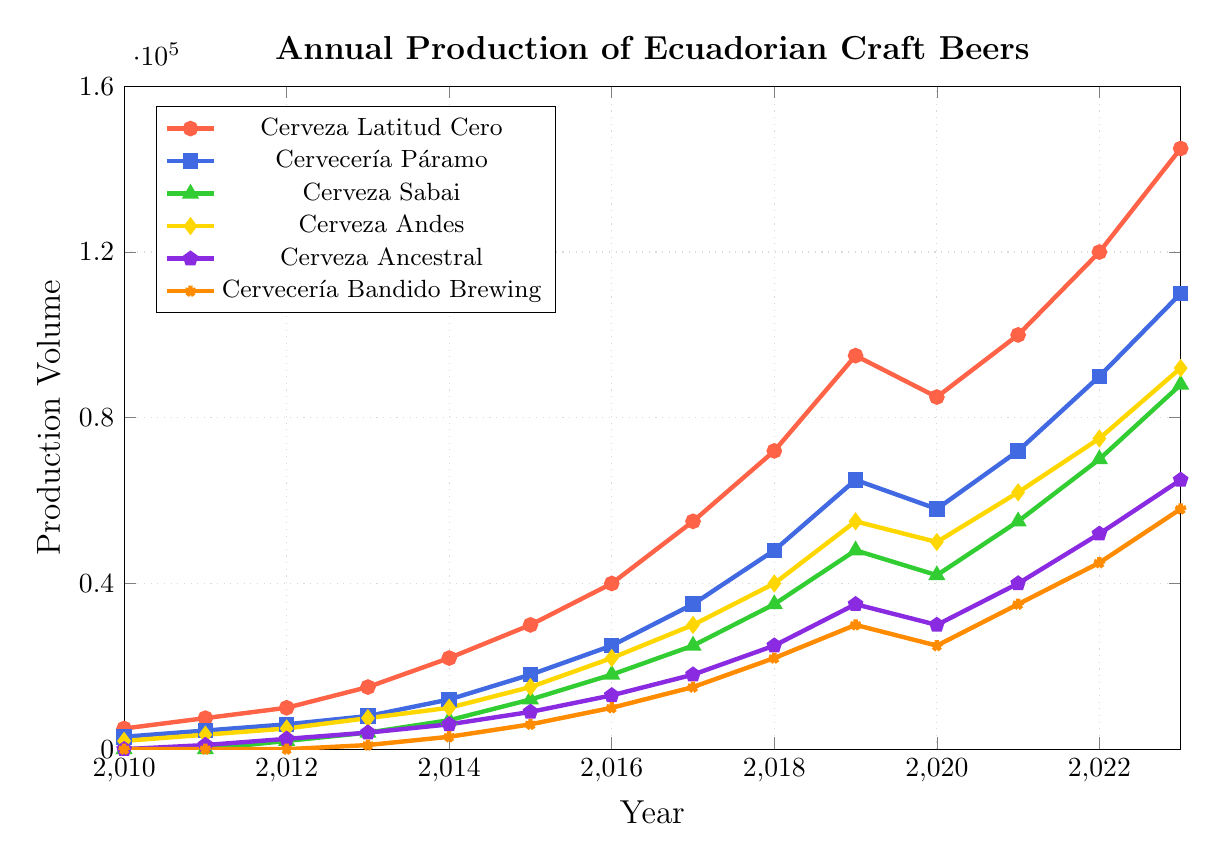What is the overall trend for Cervecería Bandido Brewing's production from 2013 to 2023? Observing the line representing Cervecería Bandido Brewing, we can see that its production volume started at 1000 in 2013 and gradually increased every year to reach 58000 in 2023.
Answer: Increasing trend Which beer had the highest production volume in 2023? Looking at the endpoints of all the lines for the year 2023, Cerveza Latitud Cero reaches the highest value at 145000.
Answer: Cerveza Latitud Cero In which year did Cerveza Sabai first reach a production volume of 10000? Following the line representing Cerveza Sabai, it first crosses the 10000 mark between the years 2015 and 2016.
Answer: 2016 Between Cerveza Andes and Cerveza Ancestral, which had a higher production volume in 2019? Comparing the lines for 2019, Cerveza Andes is at 55000 whereas Cerveza Ancestral is at 35000.
Answer: Cerveza Andes What is the difference in production volume between Cerveza Latitud Cero and Cervecería Páramo in 2018? In 2018, Cerveza Latitud Cero produced 72000 and Cervecería Páramo produced 48000. The difference is 72000 - 48000 = 24000.
Answer: 24000 What was the average production volume of Cervecería Páramo from 2010 to 2023? Summing the production values of Cervecería Páramo from 2010 to 2023 and dividing by the number of years (14), we get: (3000 + 4500 + 6000 + 8000 + 12000 + 18000 + 25000 + 35000 + 48000 + 65000 + 58000 + 72000 + 90000 + 110000)/14 = 49350.
Answer: 49350 Which beer showed the most significant production increase from 2019 to 2020? Comparing all beers' production volumes between 2019 and 2020, Cerveza Latitud Cero decreased, Cervecería Páramo decreased, Cerveza Sabai decreased, Cerveza Andes decreased, Cerveza Ancestral decreased, and Cervecería Bandido Brewing decreased. Hence, no beer showed an increase.
Answer: None What color represents Cerveza Ancestral in the chart? Observing the colors in the chart legend, Cerveza Ancestral is represented by a purple color.
Answer: Purple 